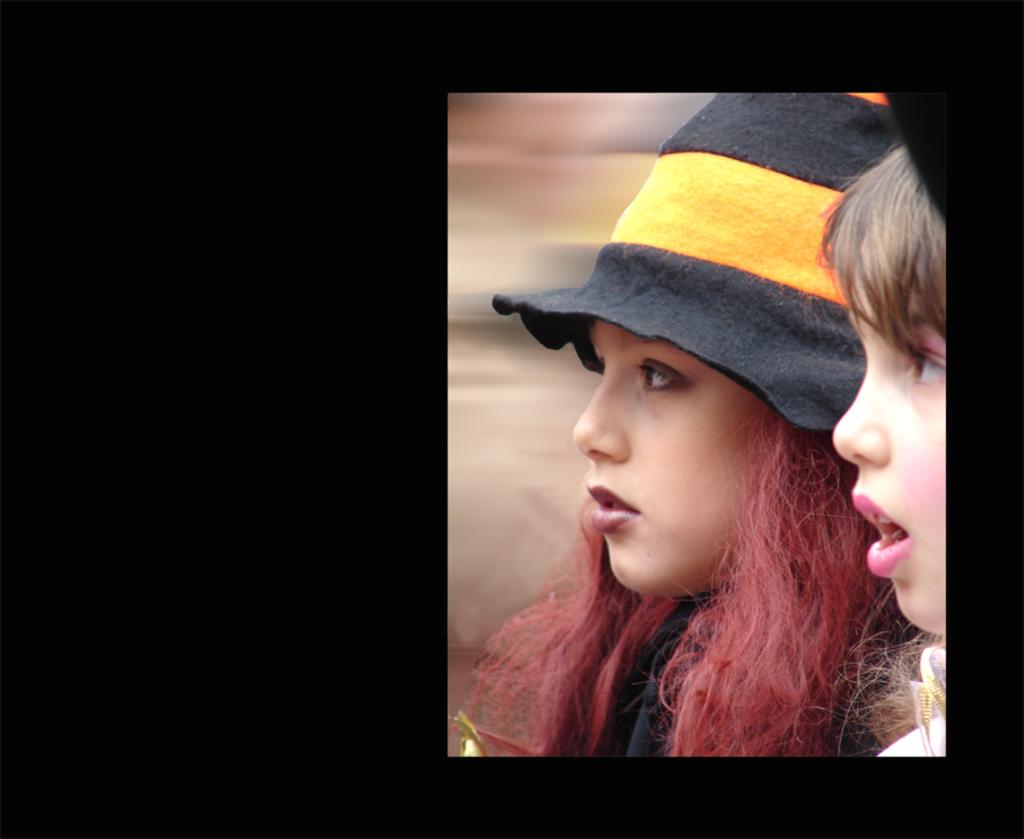How many people are in the image? There are two girls in the image. What is one of the girls wearing on her head? One of the girls is wearing a cap. What color is the background of the image? The background of the image is black. What nation is represented by the cap in the image? The cap does not represent any specific nation; it is simply a cap worn by one of the girls. How does the cap rub against the girl's head in the image? The cap does not rub against the girl's head in the image; it is stationary on her head. 